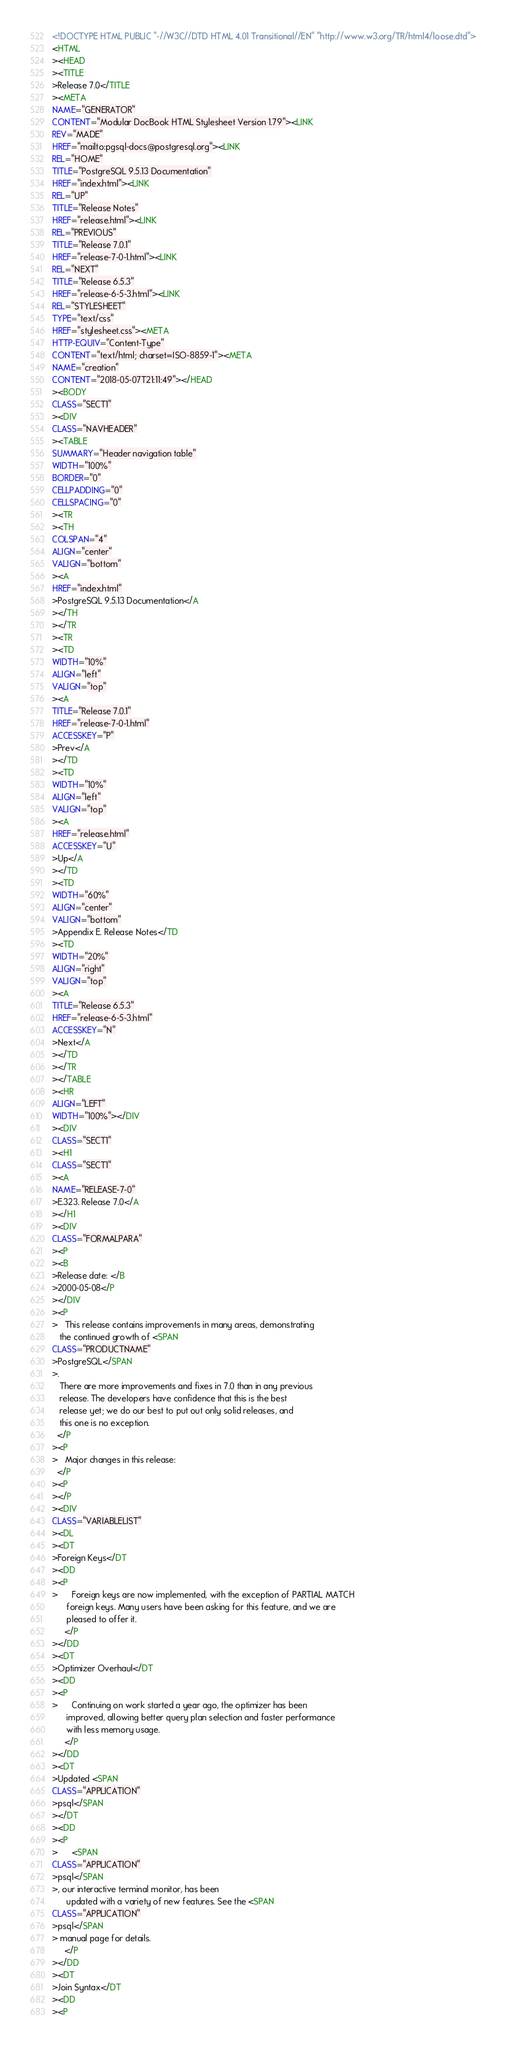<code> <loc_0><loc_0><loc_500><loc_500><_HTML_><!DOCTYPE HTML PUBLIC "-//W3C//DTD HTML 4.01 Transitional//EN" "http://www.w3.org/TR/html4/loose.dtd">
<HTML
><HEAD
><TITLE
>Release 7.0</TITLE
><META
NAME="GENERATOR"
CONTENT="Modular DocBook HTML Stylesheet Version 1.79"><LINK
REV="MADE"
HREF="mailto:pgsql-docs@postgresql.org"><LINK
REL="HOME"
TITLE="PostgreSQL 9.5.13 Documentation"
HREF="index.html"><LINK
REL="UP"
TITLE="Release Notes"
HREF="release.html"><LINK
REL="PREVIOUS"
TITLE="Release 7.0.1"
HREF="release-7-0-1.html"><LINK
REL="NEXT"
TITLE="Release 6.5.3"
HREF="release-6-5-3.html"><LINK
REL="STYLESHEET"
TYPE="text/css"
HREF="stylesheet.css"><META
HTTP-EQUIV="Content-Type"
CONTENT="text/html; charset=ISO-8859-1"><META
NAME="creation"
CONTENT="2018-05-07T21:11:49"></HEAD
><BODY
CLASS="SECT1"
><DIV
CLASS="NAVHEADER"
><TABLE
SUMMARY="Header navigation table"
WIDTH="100%"
BORDER="0"
CELLPADDING="0"
CELLSPACING="0"
><TR
><TH
COLSPAN="4"
ALIGN="center"
VALIGN="bottom"
><A
HREF="index.html"
>PostgreSQL 9.5.13 Documentation</A
></TH
></TR
><TR
><TD
WIDTH="10%"
ALIGN="left"
VALIGN="top"
><A
TITLE="Release 7.0.1"
HREF="release-7-0-1.html"
ACCESSKEY="P"
>Prev</A
></TD
><TD
WIDTH="10%"
ALIGN="left"
VALIGN="top"
><A
HREF="release.html"
ACCESSKEY="U"
>Up</A
></TD
><TD
WIDTH="60%"
ALIGN="center"
VALIGN="bottom"
>Appendix E. Release Notes</TD
><TD
WIDTH="20%"
ALIGN="right"
VALIGN="top"
><A
TITLE="Release 6.5.3"
HREF="release-6-5-3.html"
ACCESSKEY="N"
>Next</A
></TD
></TR
></TABLE
><HR
ALIGN="LEFT"
WIDTH="100%"></DIV
><DIV
CLASS="SECT1"
><H1
CLASS="SECT1"
><A
NAME="RELEASE-7-0"
>E.323. Release 7.0</A
></H1
><DIV
CLASS="FORMALPARA"
><P
><B
>Release date: </B
>2000-05-08</P
></DIV
><P
>   This release contains improvements in many areas, demonstrating
   the continued growth of <SPAN
CLASS="PRODUCTNAME"
>PostgreSQL</SPAN
>.
   There are more improvements and fixes in 7.0 than in any previous
   release. The developers have confidence that this is the best
   release yet; we do our best to put out only solid releases, and
   this one is no exception.
  </P
><P
>   Major changes in this release:
  </P
><P
></P
><DIV
CLASS="VARIABLELIST"
><DL
><DT
>Foreign Keys</DT
><DD
><P
>      Foreign keys are now implemented, with the exception of PARTIAL MATCH
      foreign keys. Many users have been asking for this feature, and we are
      pleased to offer it.
     </P
></DD
><DT
>Optimizer Overhaul</DT
><DD
><P
>      Continuing on work started a year ago, the optimizer has been
      improved, allowing better query plan selection and faster performance
      with less memory usage.
     </P
></DD
><DT
>Updated <SPAN
CLASS="APPLICATION"
>psql</SPAN
></DT
><DD
><P
>      <SPAN
CLASS="APPLICATION"
>psql</SPAN
>, our interactive terminal monitor, has been
      updated with a variety of new features. See the <SPAN
CLASS="APPLICATION"
>psql</SPAN
> manual page for details.
     </P
></DD
><DT
>Join Syntax</DT
><DD
><P</code> 